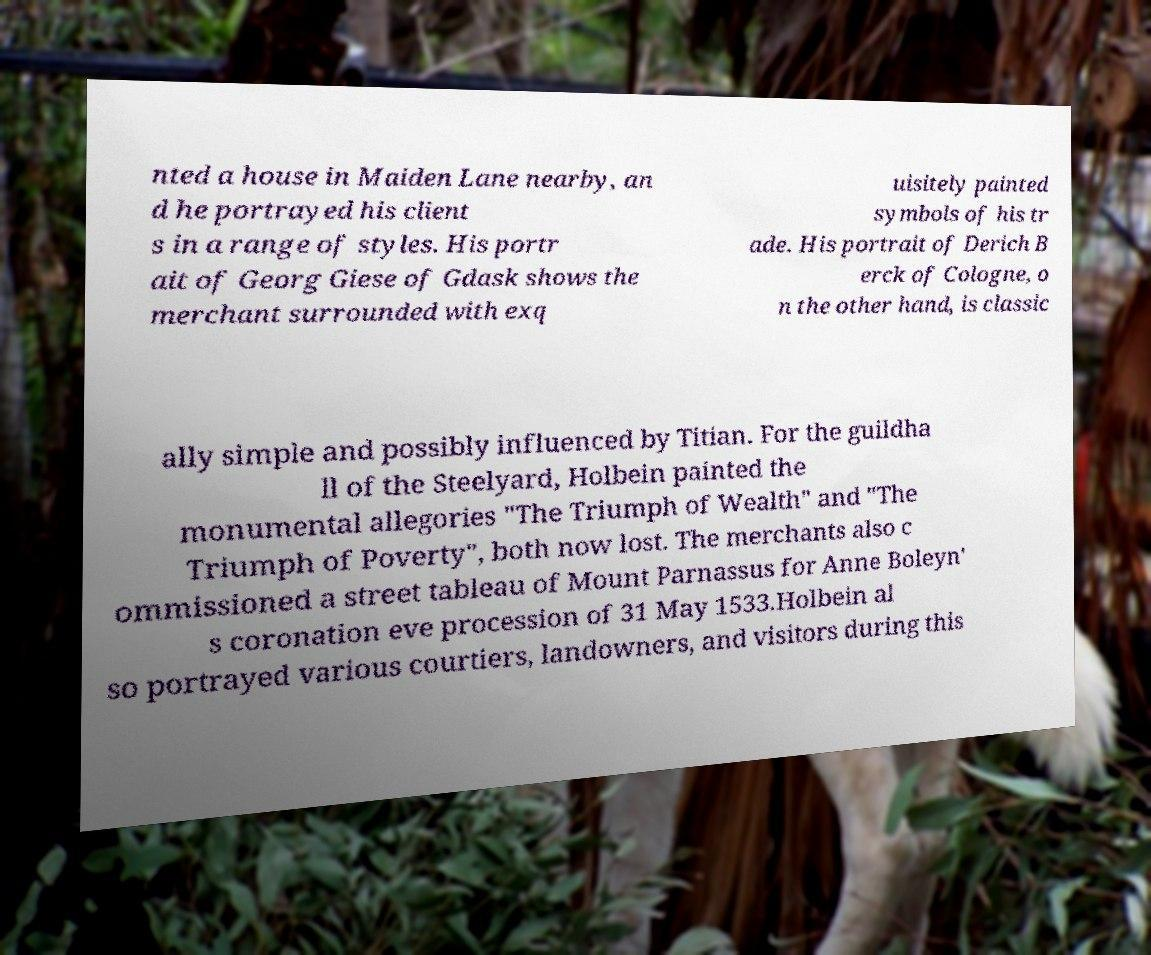Please read and relay the text visible in this image. What does it say? nted a house in Maiden Lane nearby, an d he portrayed his client s in a range of styles. His portr ait of Georg Giese of Gdask shows the merchant surrounded with exq uisitely painted symbols of his tr ade. His portrait of Derich B erck of Cologne, o n the other hand, is classic ally simple and possibly influenced by Titian. For the guildha ll of the Steelyard, Holbein painted the monumental allegories "The Triumph of Wealth" and "The Triumph of Poverty", both now lost. The merchants also c ommissioned a street tableau of Mount Parnassus for Anne Boleyn' s coronation eve procession of 31 May 1533.Holbein al so portrayed various courtiers, landowners, and visitors during this 